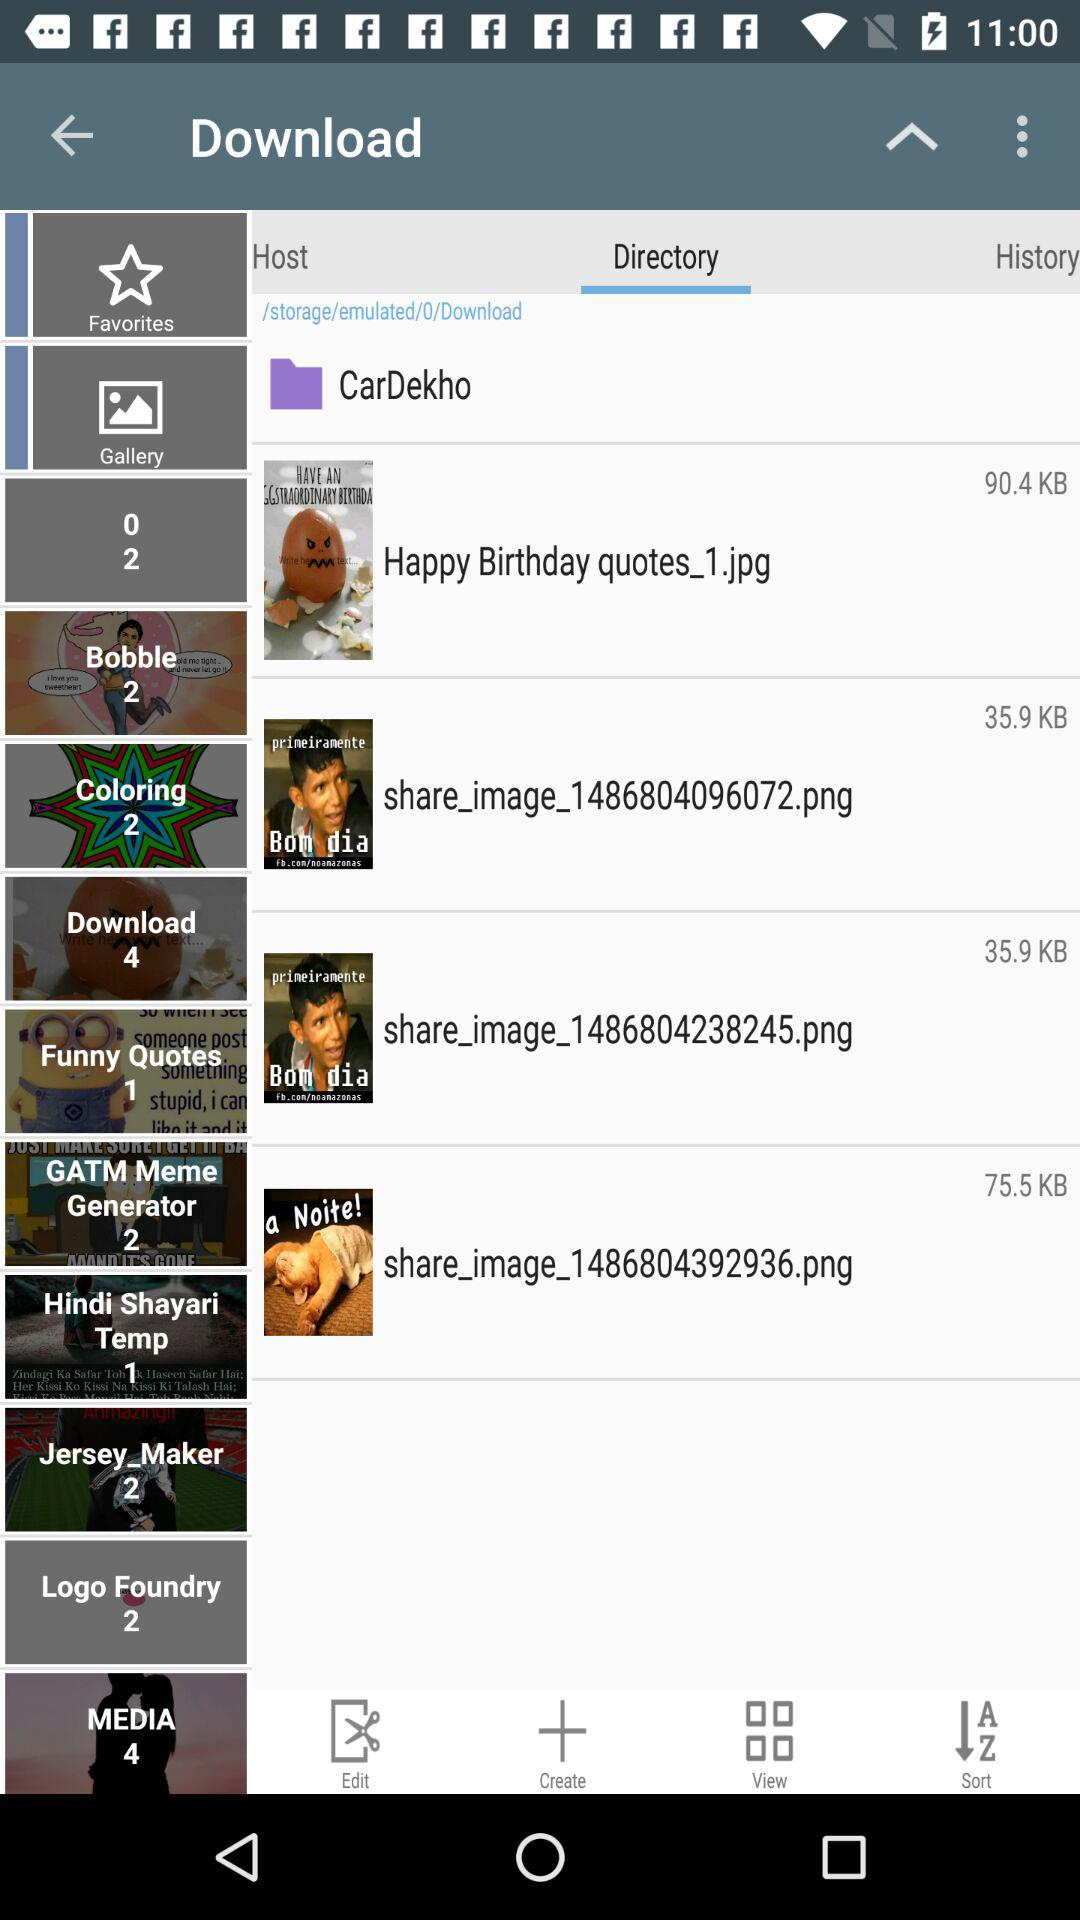What is the size of "Happy Birthday quotes_1.jpg"? The size is 90.4 KB. 